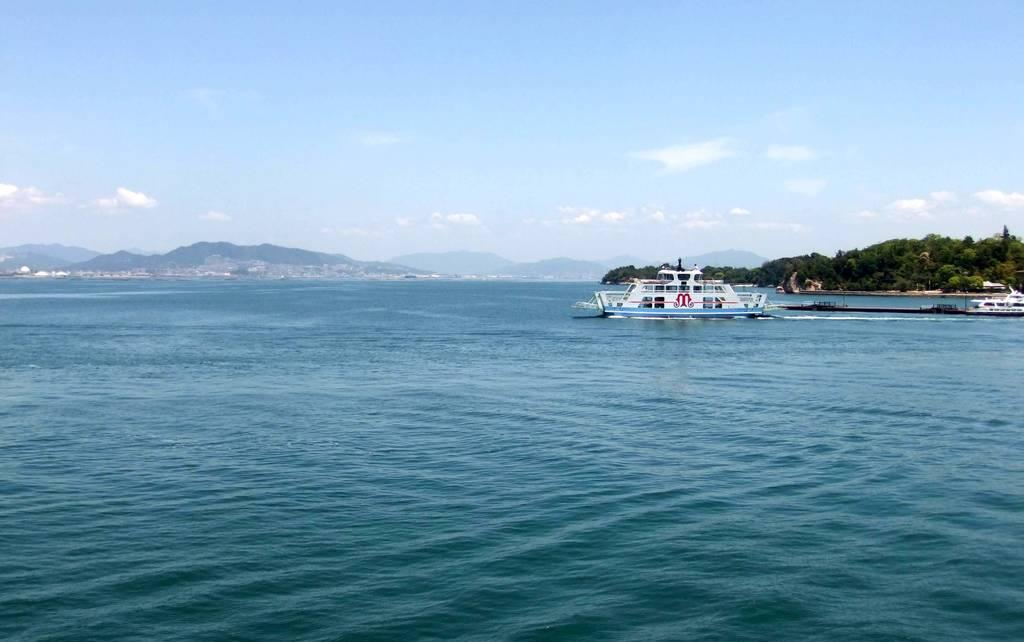What is on the water in the image? There are boats on the water in the image. What type of vegetation can be seen in the image? There are trees in the image. What geographical features are present in the image? There are hills in the image. What is visible in the background of the image? The sky is visible in the background of the image. What type of food is being served on the boats in the image? There is no food visible in the image; it only shows boats on the water, trees, hills, and the sky. Is there any blood visible in the image? No, there is no blood present in the image. 